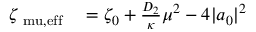Convert formula to latex. <formula><loc_0><loc_0><loc_500><loc_500>\begin{array} { r l } { \zeta _ { \ m u , e f f } } & = \zeta _ { 0 } + \frac { D _ { 2 } } { \kappa } \mu ^ { 2 } - 4 | a _ { 0 } | ^ { 2 } } \end{array}</formula> 